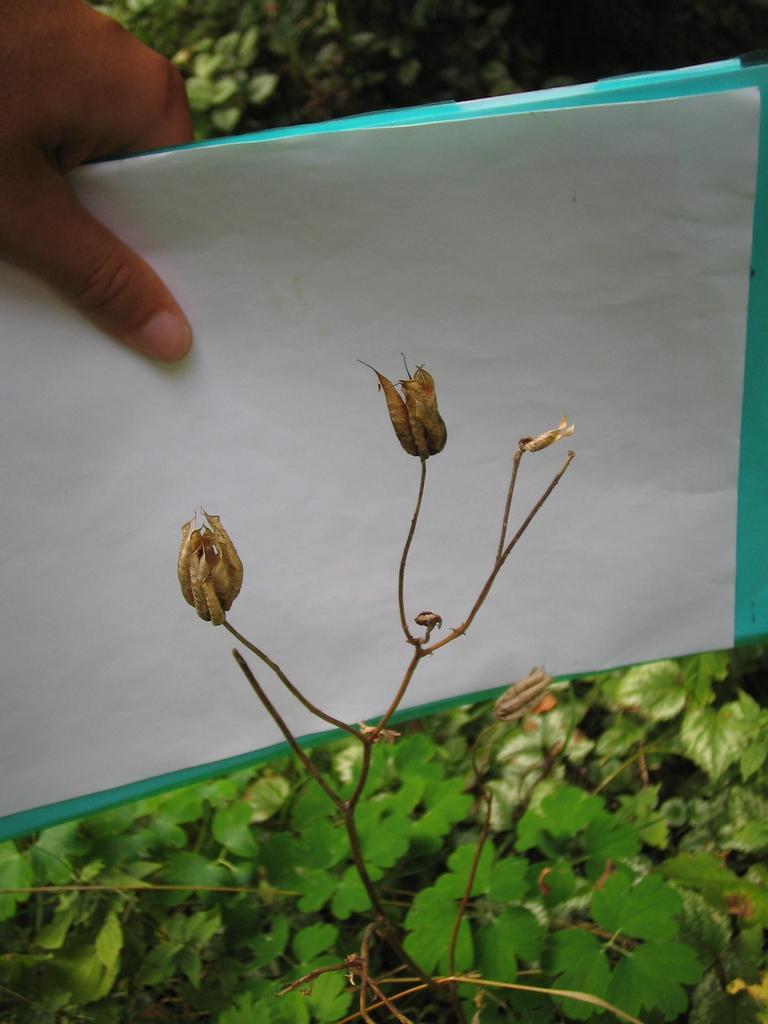How would you summarize this image in a sentence or two? In this image I can see a person is holding papers in hand, creepers and plants. This image is taken may be during a day. 